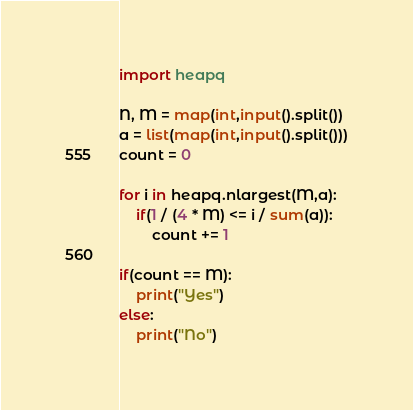Convert code to text. <code><loc_0><loc_0><loc_500><loc_500><_Python_>import heapq

N, M = map(int,input().split())
a = list(map(int,input().split()))
count = 0

for i in heapq.nlargest(M,a):
    if(1 / (4 * M) <= i / sum(a)):
        count += 1

if(count == M):
    print("Yes")
else:
    print("No")</code> 